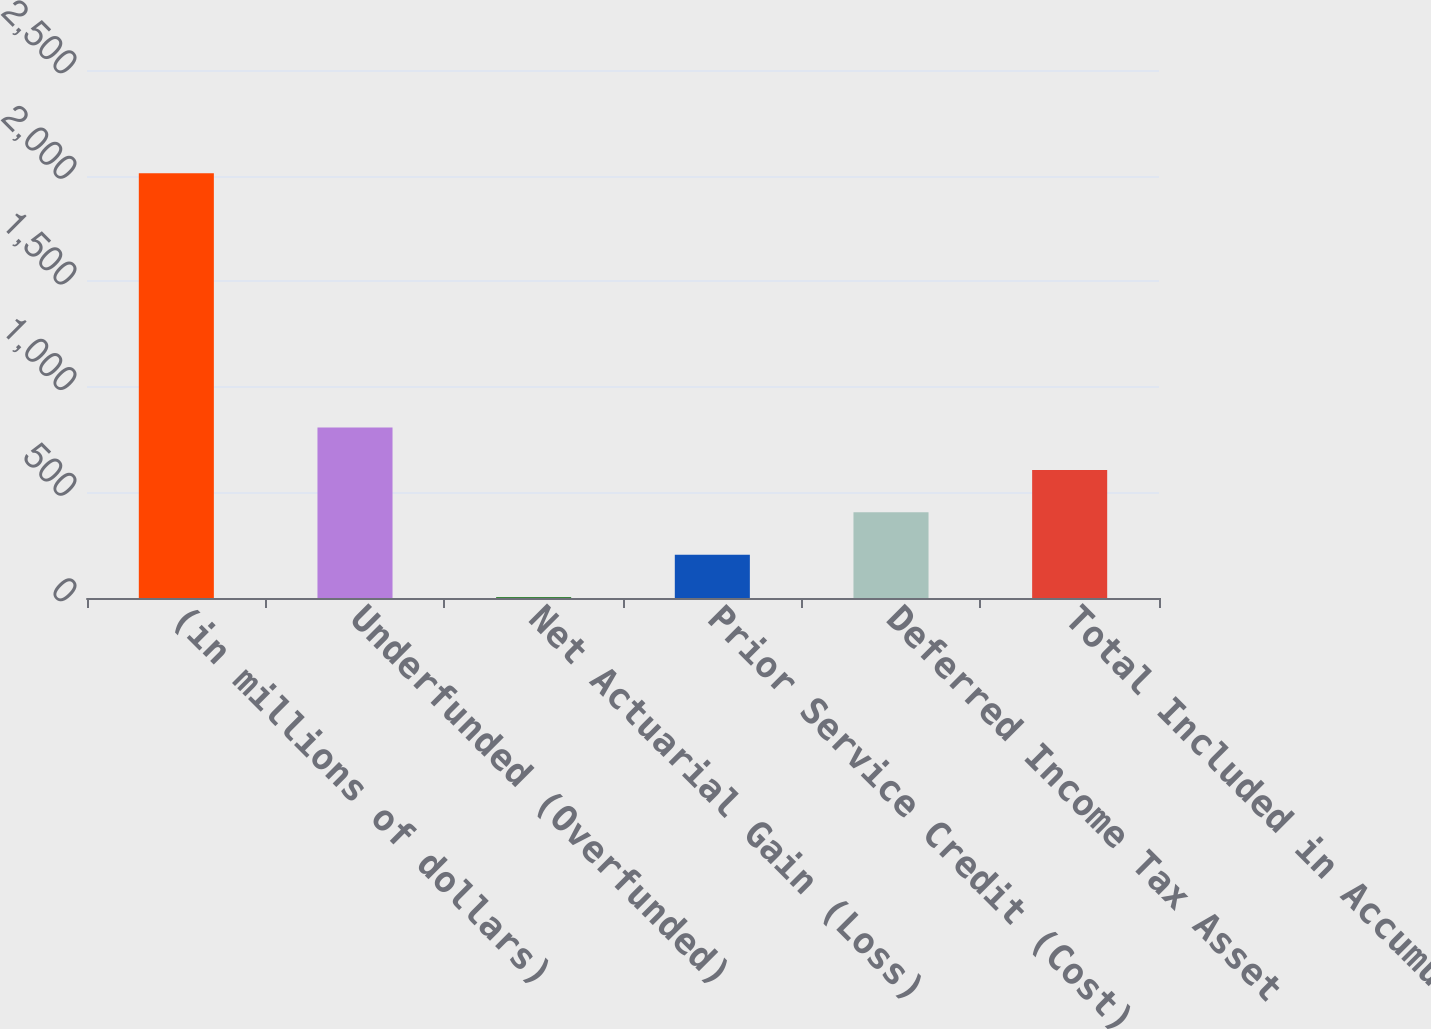Convert chart. <chart><loc_0><loc_0><loc_500><loc_500><bar_chart><fcel>(in millions of dollars)<fcel>Underfunded (Overfunded)<fcel>Net Actuarial Gain (Loss)<fcel>Prior Service Credit (Cost)<fcel>Deferred Income Tax Asset<fcel>Total Included in Accumulated<nl><fcel>2011<fcel>806.86<fcel>4.1<fcel>204.79<fcel>405.48<fcel>606.17<nl></chart> 